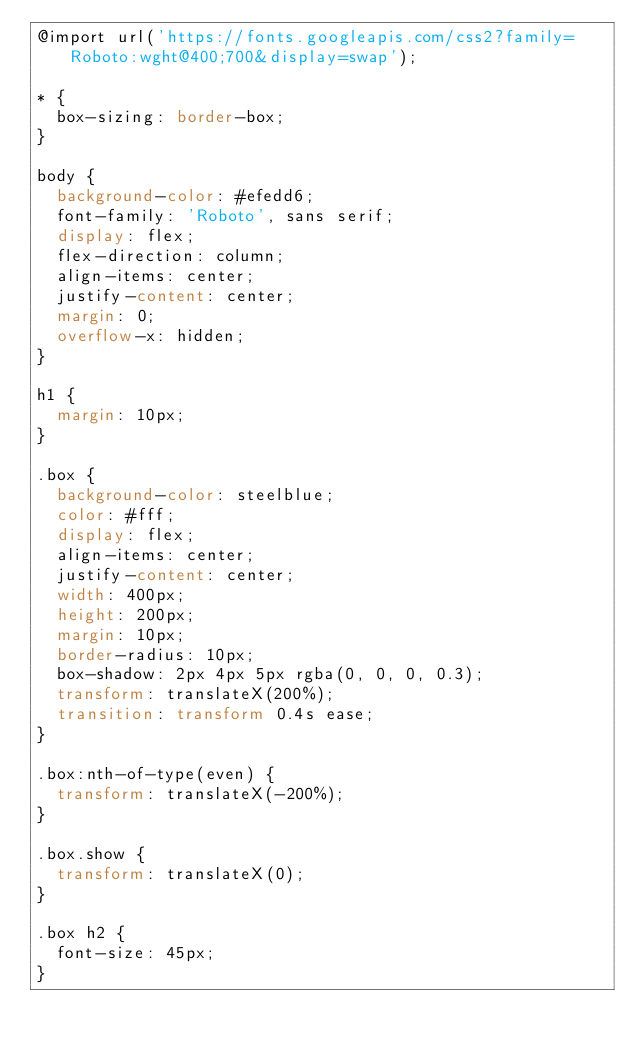<code> <loc_0><loc_0><loc_500><loc_500><_CSS_>@import url('https://fonts.googleapis.com/css2?family=Roboto:wght@400;700&display=swap');

* {
  box-sizing: border-box;
}

body {
  background-color: #efedd6;
  font-family: 'Roboto', sans serif;
  display: flex;
  flex-direction: column;
  align-items: center;
  justify-content: center;
  margin: 0;
  overflow-x: hidden;
}

h1 {
  margin: 10px;
}

.box {
  background-color: steelblue;
  color: #fff;
  display: flex;
  align-items: center;
  justify-content: center;
  width: 400px;
  height: 200px;
  margin: 10px;
  border-radius: 10px;
  box-shadow: 2px 4px 5px rgba(0, 0, 0, 0.3);
  transform: translateX(200%);
  transition: transform 0.4s ease;
}

.box:nth-of-type(even) {
  transform: translateX(-200%);
}

.box.show {
  transform: translateX(0);
}

.box h2 {
  font-size: 45px;
}
</code> 